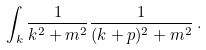<formula> <loc_0><loc_0><loc_500><loc_500>\int _ { k } { \frac { 1 } { k ^ { 2 } + m ^ { 2 } } } { \frac { 1 } { ( k + p ) ^ { 2 } + m ^ { 2 } } } \, .</formula> 